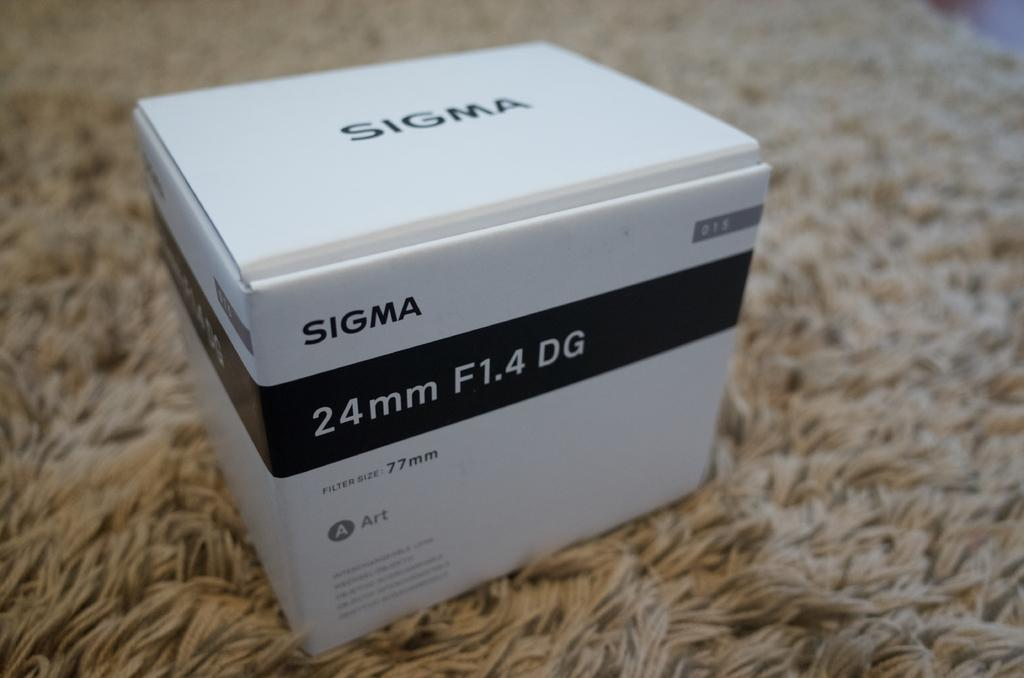<image>
Create a compact narrative representing the image presented. A box of 24mm Sigma film sits on a carpet. 